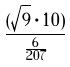Convert formula to latex. <formula><loc_0><loc_0><loc_500><loc_500>\frac { ( \sqrt { 9 } \cdot 1 0 ) } { \frac { 6 } { 2 0 7 } }</formula> 